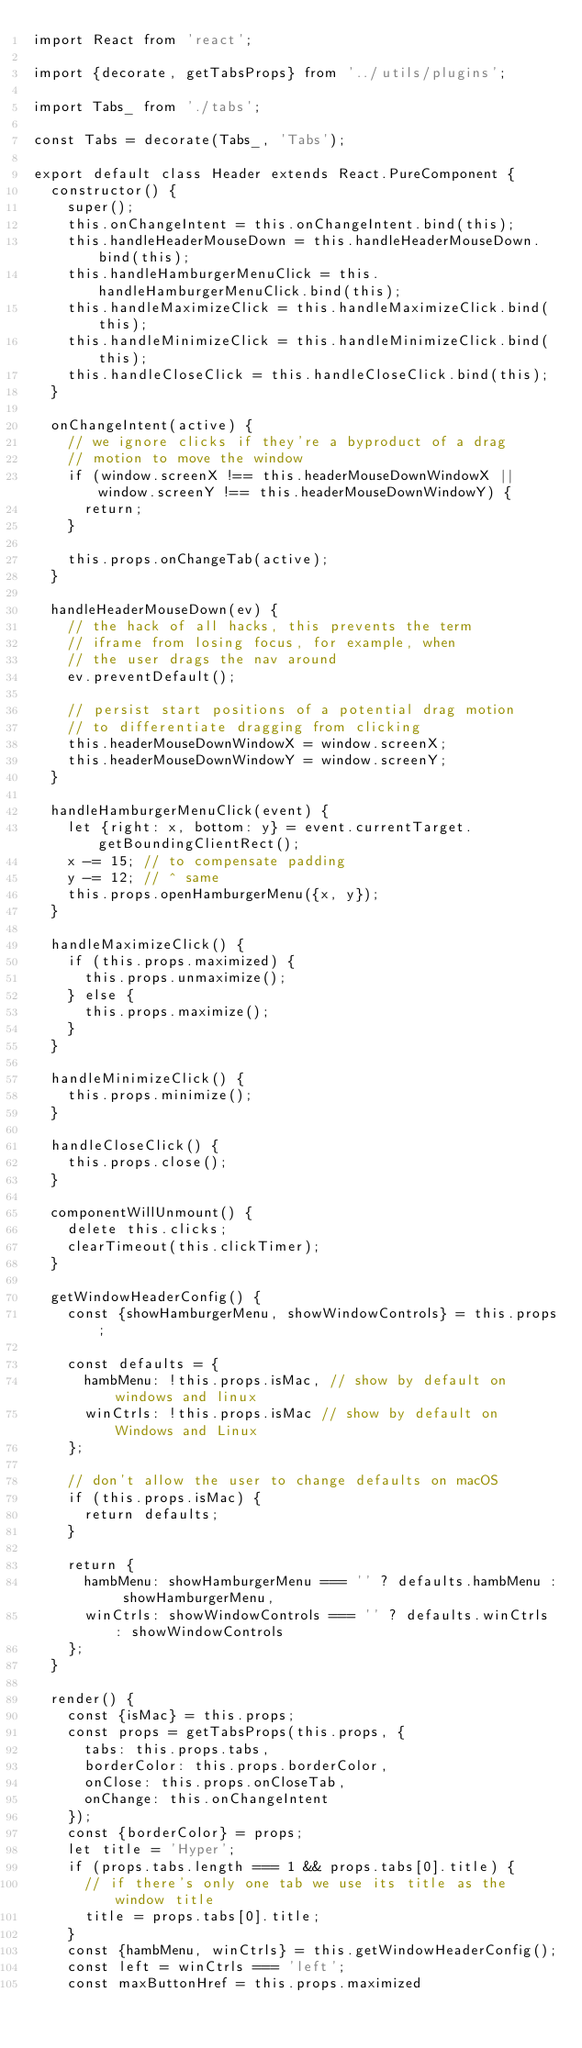Convert code to text. <code><loc_0><loc_0><loc_500><loc_500><_JavaScript_>import React from 'react';

import {decorate, getTabsProps} from '../utils/plugins';

import Tabs_ from './tabs';

const Tabs = decorate(Tabs_, 'Tabs');

export default class Header extends React.PureComponent {
  constructor() {
    super();
    this.onChangeIntent = this.onChangeIntent.bind(this);
    this.handleHeaderMouseDown = this.handleHeaderMouseDown.bind(this);
    this.handleHamburgerMenuClick = this.handleHamburgerMenuClick.bind(this);
    this.handleMaximizeClick = this.handleMaximizeClick.bind(this);
    this.handleMinimizeClick = this.handleMinimizeClick.bind(this);
    this.handleCloseClick = this.handleCloseClick.bind(this);
  }

  onChangeIntent(active) {
    // we ignore clicks if they're a byproduct of a drag
    // motion to move the window
    if (window.screenX !== this.headerMouseDownWindowX || window.screenY !== this.headerMouseDownWindowY) {
      return;
    }

    this.props.onChangeTab(active);
  }

  handleHeaderMouseDown(ev) {
    // the hack of all hacks, this prevents the term
    // iframe from losing focus, for example, when
    // the user drags the nav around
    ev.preventDefault();

    // persist start positions of a potential drag motion
    // to differentiate dragging from clicking
    this.headerMouseDownWindowX = window.screenX;
    this.headerMouseDownWindowY = window.screenY;
  }

  handleHamburgerMenuClick(event) {
    let {right: x, bottom: y} = event.currentTarget.getBoundingClientRect();
    x -= 15; // to compensate padding
    y -= 12; // ^ same
    this.props.openHamburgerMenu({x, y});
  }

  handleMaximizeClick() {
    if (this.props.maximized) {
      this.props.unmaximize();
    } else {
      this.props.maximize();
    }
  }

  handleMinimizeClick() {
    this.props.minimize();
  }

  handleCloseClick() {
    this.props.close();
  }

  componentWillUnmount() {
    delete this.clicks;
    clearTimeout(this.clickTimer);
  }

  getWindowHeaderConfig() {
    const {showHamburgerMenu, showWindowControls} = this.props;

    const defaults = {
      hambMenu: !this.props.isMac, // show by default on windows and linux
      winCtrls: !this.props.isMac // show by default on Windows and Linux
    };

    // don't allow the user to change defaults on macOS
    if (this.props.isMac) {
      return defaults;
    }

    return {
      hambMenu: showHamburgerMenu === '' ? defaults.hambMenu : showHamburgerMenu,
      winCtrls: showWindowControls === '' ? defaults.winCtrls : showWindowControls
    };
  }

  render() {
    const {isMac} = this.props;
    const props = getTabsProps(this.props, {
      tabs: this.props.tabs,
      borderColor: this.props.borderColor,
      onClose: this.props.onCloseTab,
      onChange: this.onChangeIntent
    });
    const {borderColor} = props;
    let title = 'Hyper';
    if (props.tabs.length === 1 && props.tabs[0].title) {
      // if there's only one tab we use its title as the window title
      title = props.tabs[0].title;
    }
    const {hambMenu, winCtrls} = this.getWindowHeaderConfig();
    const left = winCtrls === 'left';
    const maxButtonHref = this.props.maximized</code> 